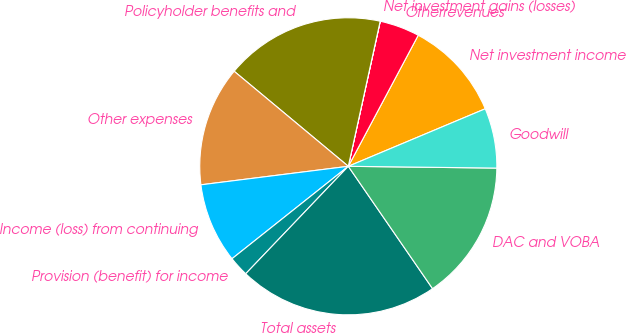Convert chart to OTSL. <chart><loc_0><loc_0><loc_500><loc_500><pie_chart><fcel>Net investment income<fcel>Otherrevenues<fcel>Net investment gains (losses)<fcel>Policyholder benefits and<fcel>Other expenses<fcel>Income (loss) from continuing<fcel>Provision (benefit) for income<fcel>Total assets<fcel>DAC and VOBA<fcel>Goodwill<nl><fcel>10.87%<fcel>4.35%<fcel>0.01%<fcel>17.39%<fcel>13.04%<fcel>8.7%<fcel>2.18%<fcel>21.73%<fcel>15.21%<fcel>6.52%<nl></chart> 